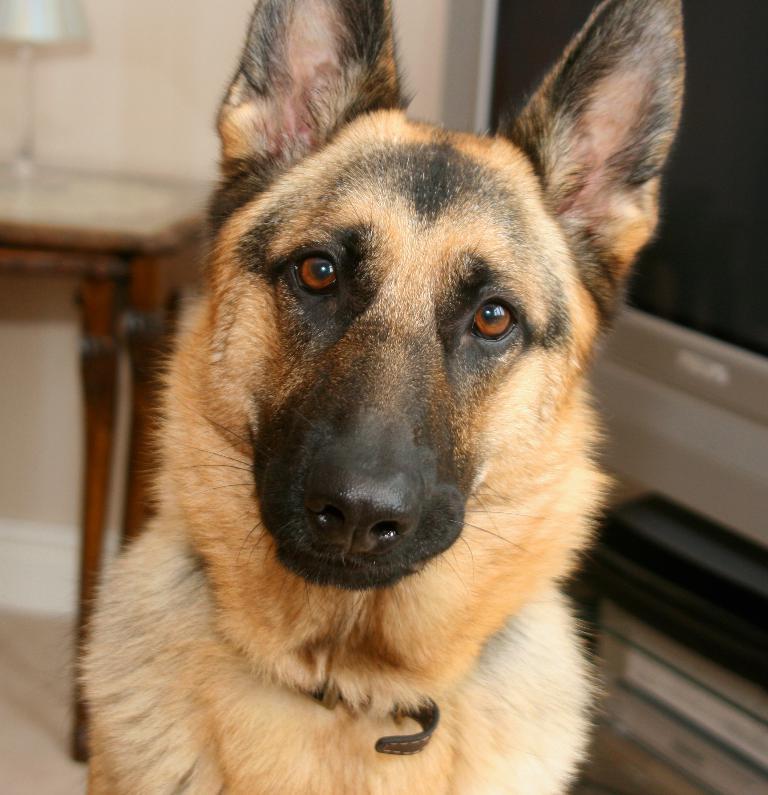In one or two sentences, can you explain what this image depicts? In this picture I can see there is a dog sitting on the floor and in the backdrop there is a table and there is a television. 